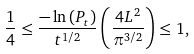<formula> <loc_0><loc_0><loc_500><loc_500>\frac { 1 } { 4 } \leq \frac { - \ln \left ( P _ { t } \right ) } { t ^ { 1 / 2 } } \left ( \frac { 4 L ^ { 2 } } { \pi ^ { 3 / 2 } } \right ) \leq 1 ,</formula> 